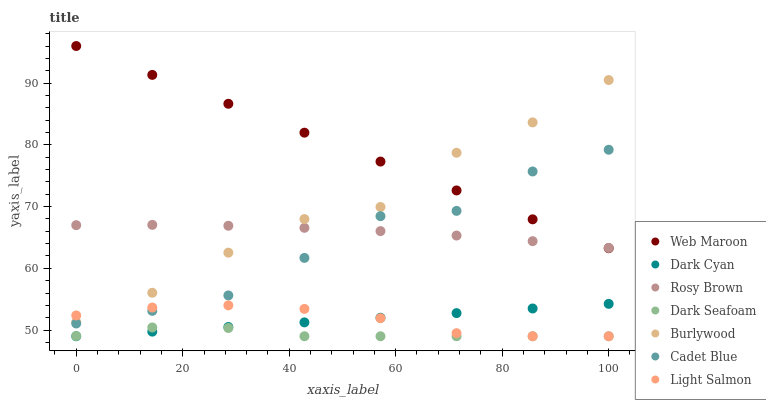Does Dark Seafoam have the minimum area under the curve?
Answer yes or no. Yes. Does Web Maroon have the maximum area under the curve?
Answer yes or no. Yes. Does Cadet Blue have the minimum area under the curve?
Answer yes or no. No. Does Cadet Blue have the maximum area under the curve?
Answer yes or no. No. Is Dark Cyan the smoothest?
Answer yes or no. Yes. Is Cadet Blue the roughest?
Answer yes or no. Yes. Is Burlywood the smoothest?
Answer yes or no. No. Is Burlywood the roughest?
Answer yes or no. No. Does Light Salmon have the lowest value?
Answer yes or no. Yes. Does Cadet Blue have the lowest value?
Answer yes or no. No. Does Web Maroon have the highest value?
Answer yes or no. Yes. Does Cadet Blue have the highest value?
Answer yes or no. No. Is Cadet Blue less than Burlywood?
Answer yes or no. Yes. Is Web Maroon greater than Dark Seafoam?
Answer yes or no. Yes. Does Cadet Blue intersect Rosy Brown?
Answer yes or no. Yes. Is Cadet Blue less than Rosy Brown?
Answer yes or no. No. Is Cadet Blue greater than Rosy Brown?
Answer yes or no. No. Does Cadet Blue intersect Burlywood?
Answer yes or no. No. 